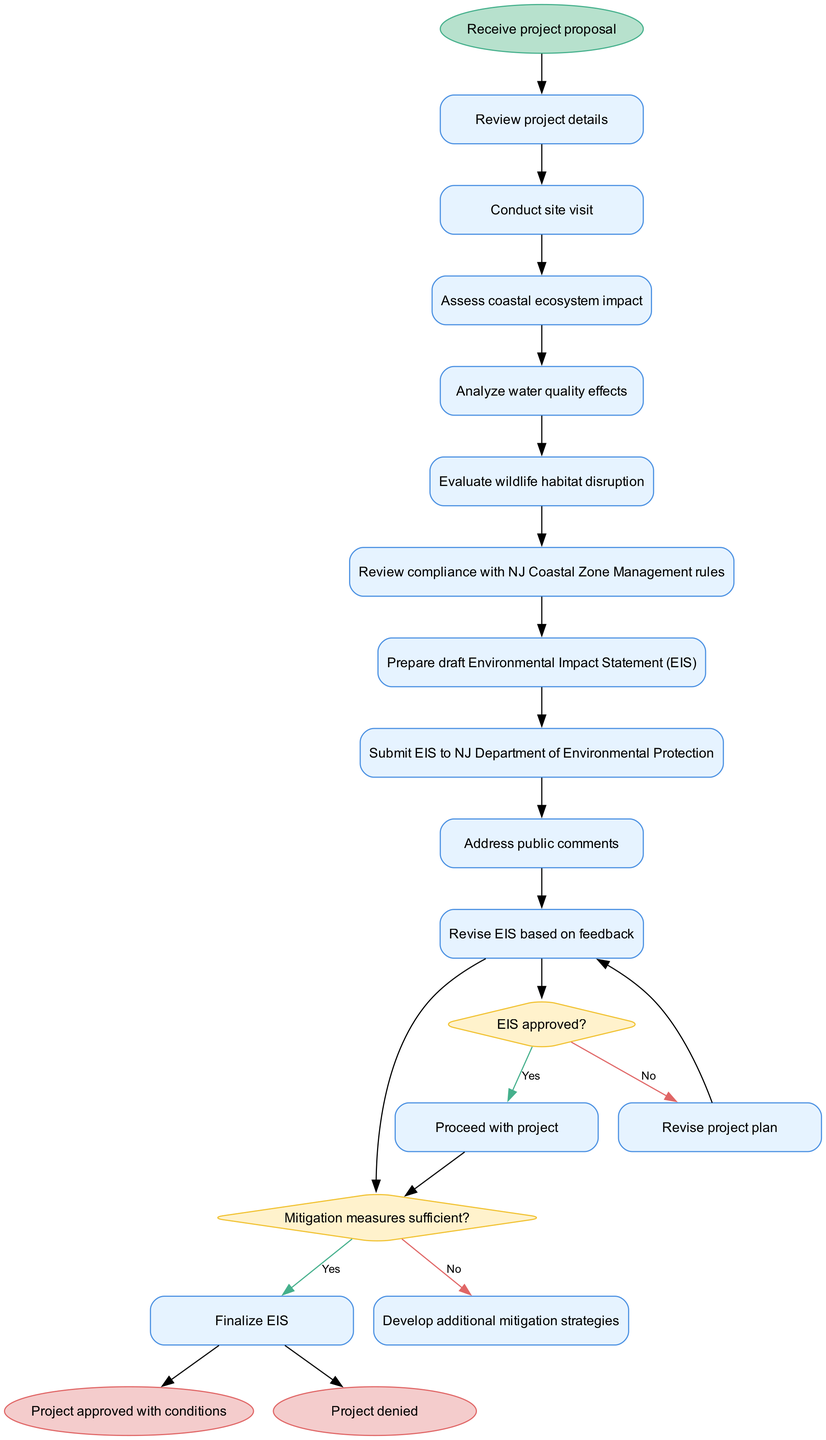What is the starting node of the process? The starting node of the process is indicated by the label on the first oval shape in the diagram. It is the first node that initiates the activity flow.
Answer: Receive project proposal How many activities are present in the diagram? The number of activities can be counted directly from the list of activities in the diagram, which are represented by rectangular nodes. There are ten activities listed.
Answer: 10 What is the last activity before the first decision node? The last activity before the first decision node is the final activity that connects to the decision point. This can be traced from the flow of activities to the decision symbol.
Answer: Submit EIS to NJ Department of Environmental Protection What happens if the EIS is approved? If the EIS is approved, the flow indicates that the process moves to the next step with a 'yes' decision, which leads to project approval.
Answer: Proceed with project What will occur if the mitigation measures are not sufficient? If the mitigation measures are determined to be insufficient, the flow indicates that further steps must be taken to develop additional strategies before moving forward.
Answer: Develop additional mitigation strategies How many decision nodes are present in the diagram? The number of decision nodes can be counted by identifying the diamond-shaped nodes within the diagram. There are two decision nodes visible.
Answer: 2 If the project plan is revised, what is the next step? If the project plan needs to be revised, the flow indicates that it would loop back to the last activity, which is the submission of the EIS. Thus, it leads back to a point where further review occurs.
Answer: Revise project plan What is the final outcome if the EIS is finalized? The final outcome can be deduced from following the last decision node flow points after the EIS is finalized. It will lead towards the concluding step based on approval conditions.
Answer: Project approved with conditions 